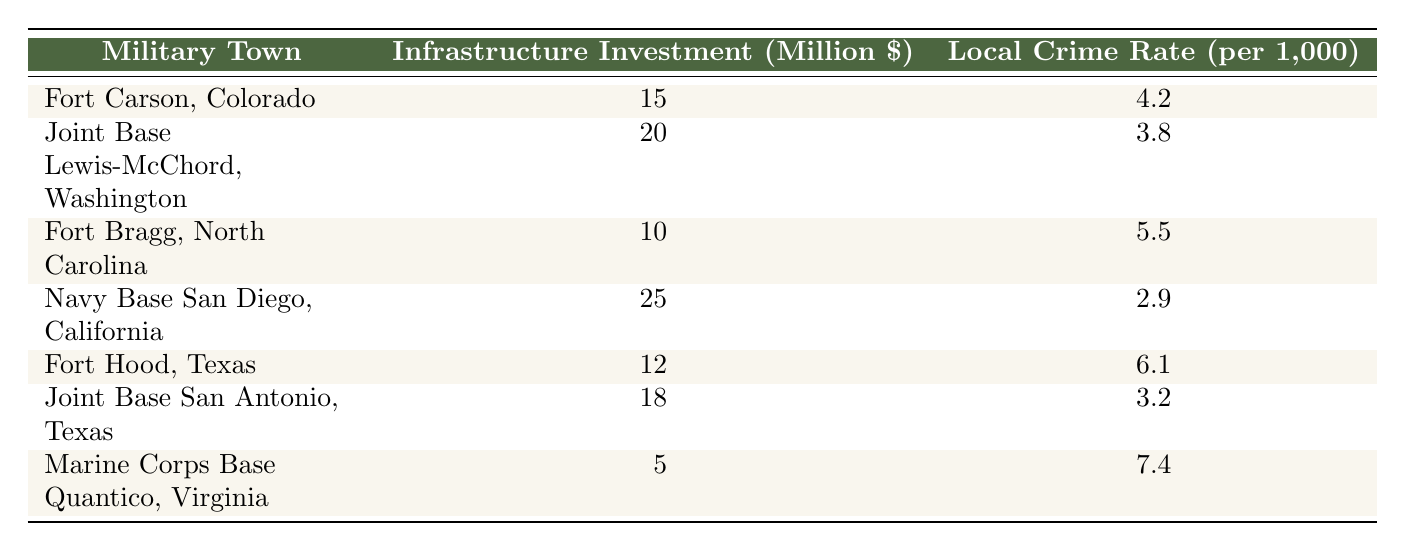What is the local crime rate for Navy Base San Diego, California? According to the table, Navy Base San Diego, California has a local crime rate of 2.9 per 1,000.
Answer: 2.9 Which military town has the highest infrastructure investment? The table shows that Navy Base San Diego, California has the highest infrastructure investment at 25 million dollars.
Answer: 25 What is the average local crime rate for military towns with an investment of 15 million or more? The towns with an investment of 15 million or more are Fort Carson (4.2), Joint Base Lewis-McChord (3.8), Navy Base San Diego (2.9), Joint Base San Antonio (3.2), and Fort Hood (6.1). Adding these rates gives 4.2 + 3.8 + 2.9 + 3.2 + 6.1 = 20.2, and dividing by 5 yields an average of 4.04.
Answer: 4.04 Does an increase in infrastructure investment correlate with a decrease in local crime rates? Evaluating the towns with higher infrastructure investments tends to show lower crime rates; for instance, Navy Base San Diego with 25 million has the lowest crime rate of 2.9, while Marine Corps Base Quantico with only 5 million has the highest crime rate of 7.4. This suggests a correlation, though more data would be needed for a definitive conclusion.
Answer: Yes What is the difference in crime rates between the town with the lowest and highest crime rates? The town with the lowest crime rate is Navy Base San Diego at 2.9 and the highest is Marine Corps Base Quantico at 7.4. The difference is calculated as 7.4 - 2.9 = 4.5.
Answer: 4.5 How many towns have a crime rate greater than 5 per 1,000? From the table, the towns with a crime rate greater than 5 per 1,000 are Fort Bragg (5.5), Fort Hood (6.1), and Marine Corps Base Quantico (7.4). This totals to three towns.
Answer: 3 What infrastructure investment corresponds to the second lowest crime rate? The second lowest crime rate in the data is for Joint Base Lewis-McChord, which has a crime rate of 3.8 and the infrastructure investment for this town is 20 million.
Answer: 20 Is it true that all military towns listed have a crime rate below 8 per 1,000? Looking at the table, all towns have crime rates under 8 per 1,000, with the highest being 7.4 for Marine Corps Base Quantico. Thus, this statement is true.
Answer: Yes 